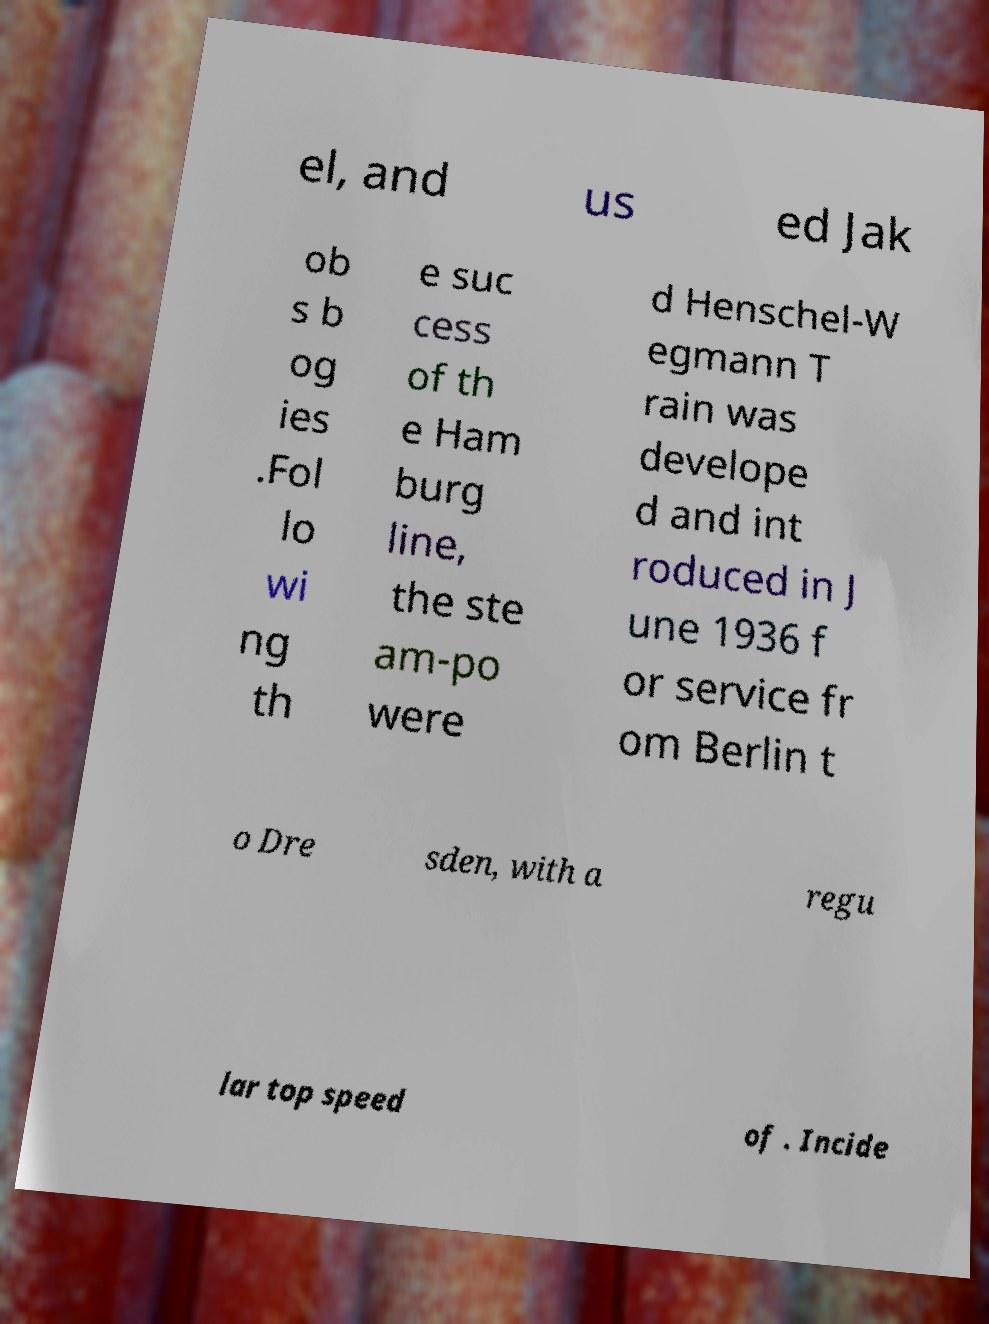Please read and relay the text visible in this image. What does it say? el, and us ed Jak ob s b og ies .Fol lo wi ng th e suc cess of th e Ham burg line, the ste am-po were d Henschel-W egmann T rain was develope d and int roduced in J une 1936 f or service fr om Berlin t o Dre sden, with a regu lar top speed of . Incide 